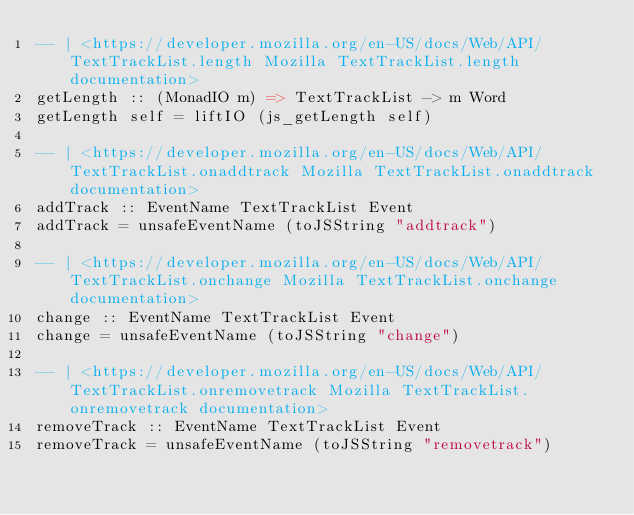<code> <loc_0><loc_0><loc_500><loc_500><_Haskell_>-- | <https://developer.mozilla.org/en-US/docs/Web/API/TextTrackList.length Mozilla TextTrackList.length documentation> 
getLength :: (MonadIO m) => TextTrackList -> m Word
getLength self = liftIO (js_getLength self)

-- | <https://developer.mozilla.org/en-US/docs/Web/API/TextTrackList.onaddtrack Mozilla TextTrackList.onaddtrack documentation> 
addTrack :: EventName TextTrackList Event
addTrack = unsafeEventName (toJSString "addtrack")

-- | <https://developer.mozilla.org/en-US/docs/Web/API/TextTrackList.onchange Mozilla TextTrackList.onchange documentation> 
change :: EventName TextTrackList Event
change = unsafeEventName (toJSString "change")

-- | <https://developer.mozilla.org/en-US/docs/Web/API/TextTrackList.onremovetrack Mozilla TextTrackList.onremovetrack documentation> 
removeTrack :: EventName TextTrackList Event
removeTrack = unsafeEventName (toJSString "removetrack")</code> 